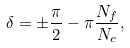<formula> <loc_0><loc_0><loc_500><loc_500>\delta = \pm \frac { \pi } 2 - \pi \frac { N _ { f } } { N _ { c } } ,</formula> 